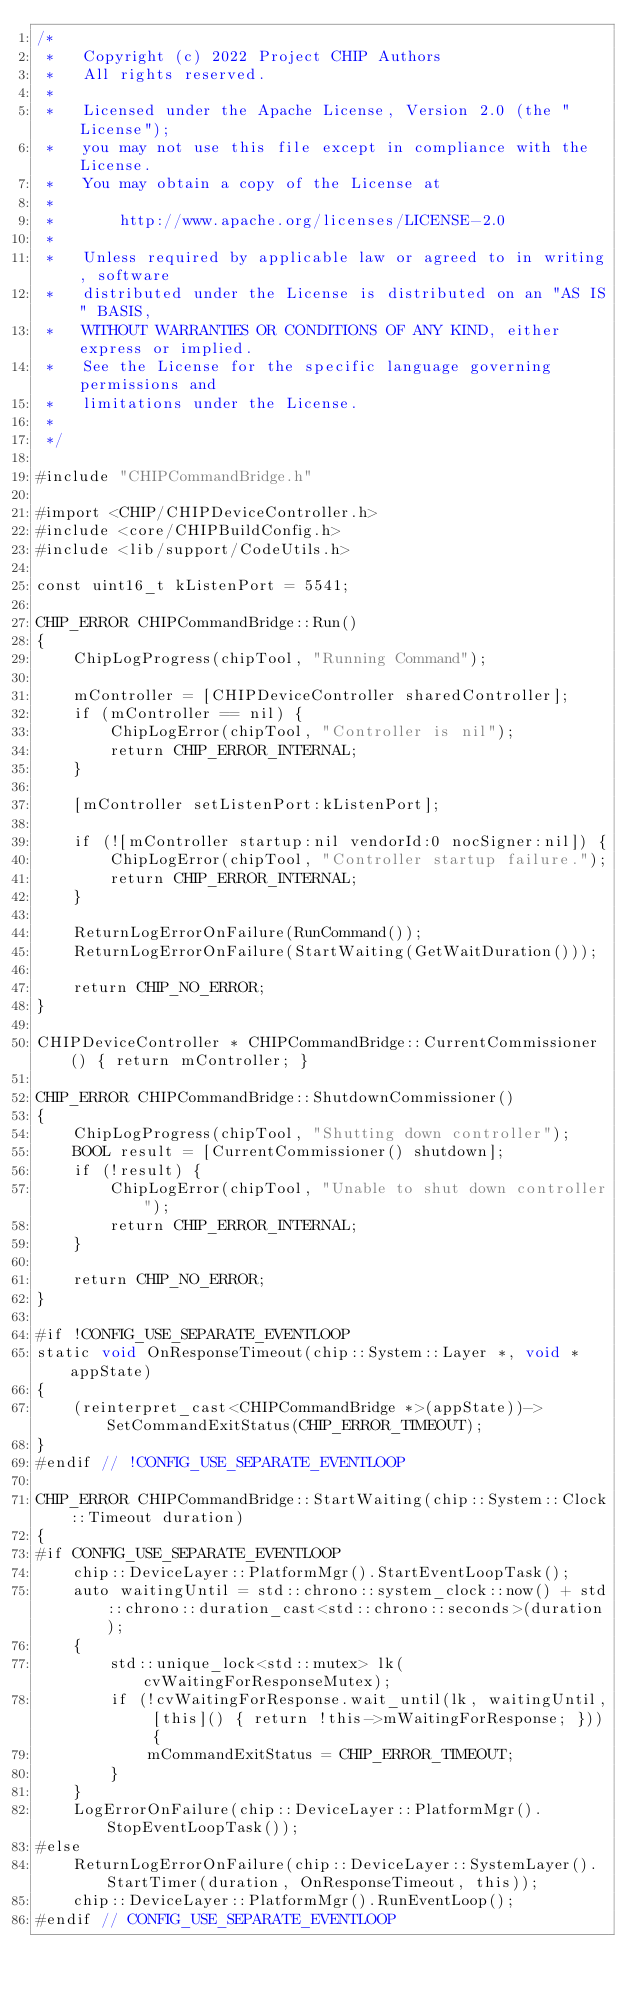Convert code to text. <code><loc_0><loc_0><loc_500><loc_500><_ObjectiveC_>/*
 *   Copyright (c) 2022 Project CHIP Authors
 *   All rights reserved.
 *
 *   Licensed under the Apache License, Version 2.0 (the "License");
 *   you may not use this file except in compliance with the License.
 *   You may obtain a copy of the License at
 *
 *       http://www.apache.org/licenses/LICENSE-2.0
 *
 *   Unless required by applicable law or agreed to in writing, software
 *   distributed under the License is distributed on an "AS IS" BASIS,
 *   WITHOUT WARRANTIES OR CONDITIONS OF ANY KIND, either express or implied.
 *   See the License for the specific language governing permissions and
 *   limitations under the License.
 *
 */

#include "CHIPCommandBridge.h"

#import <CHIP/CHIPDeviceController.h>
#include <core/CHIPBuildConfig.h>
#include <lib/support/CodeUtils.h>

const uint16_t kListenPort = 5541;

CHIP_ERROR CHIPCommandBridge::Run()
{
    ChipLogProgress(chipTool, "Running Command");

    mController = [CHIPDeviceController sharedController];
    if (mController == nil) {
        ChipLogError(chipTool, "Controller is nil");
        return CHIP_ERROR_INTERNAL;
    }

    [mController setListenPort:kListenPort];

    if (![mController startup:nil vendorId:0 nocSigner:nil]) {
        ChipLogError(chipTool, "Controller startup failure.");
        return CHIP_ERROR_INTERNAL;
    }

    ReturnLogErrorOnFailure(RunCommand());
    ReturnLogErrorOnFailure(StartWaiting(GetWaitDuration()));

    return CHIP_NO_ERROR;
}

CHIPDeviceController * CHIPCommandBridge::CurrentCommissioner() { return mController; }

CHIP_ERROR CHIPCommandBridge::ShutdownCommissioner()
{
    ChipLogProgress(chipTool, "Shutting down controller");
    BOOL result = [CurrentCommissioner() shutdown];
    if (!result) {
        ChipLogError(chipTool, "Unable to shut down controller");
        return CHIP_ERROR_INTERNAL;
    }

    return CHIP_NO_ERROR;
}

#if !CONFIG_USE_SEPARATE_EVENTLOOP
static void OnResponseTimeout(chip::System::Layer *, void * appState)
{
    (reinterpret_cast<CHIPCommandBridge *>(appState))->SetCommandExitStatus(CHIP_ERROR_TIMEOUT);
}
#endif // !CONFIG_USE_SEPARATE_EVENTLOOP

CHIP_ERROR CHIPCommandBridge::StartWaiting(chip::System::Clock::Timeout duration)
{
#if CONFIG_USE_SEPARATE_EVENTLOOP
    chip::DeviceLayer::PlatformMgr().StartEventLoopTask();
    auto waitingUntil = std::chrono::system_clock::now() + std::chrono::duration_cast<std::chrono::seconds>(duration);
    {
        std::unique_lock<std::mutex> lk(cvWaitingForResponseMutex);
        if (!cvWaitingForResponse.wait_until(lk, waitingUntil, [this]() { return !this->mWaitingForResponse; })) {
            mCommandExitStatus = CHIP_ERROR_TIMEOUT;
        }
    }
    LogErrorOnFailure(chip::DeviceLayer::PlatformMgr().StopEventLoopTask());
#else
    ReturnLogErrorOnFailure(chip::DeviceLayer::SystemLayer().StartTimer(duration, OnResponseTimeout, this));
    chip::DeviceLayer::PlatformMgr().RunEventLoop();
#endif // CONFIG_USE_SEPARATE_EVENTLOOP
</code> 